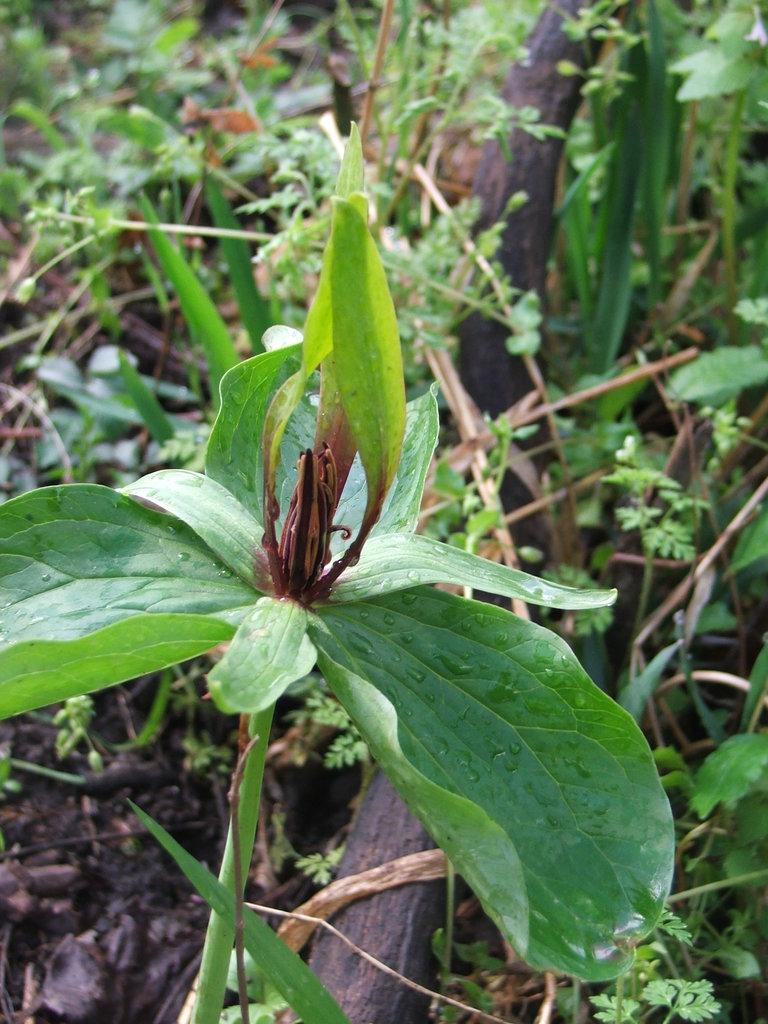What type of living organism can be seen in the image? There is a plant in the image. What is the condition of the plant in the image? Dew is visible on the plant. What object is made of wood in the image? There is a wooden stick in the image. Can you describe a part of the image that is not clear? There is a blurred part of the image. What type of scarecrow is visible in the image? There is no scarecrow present in the image. How does the balloon affect the visibility of the plant in the image? There is no balloon present in the image, so it cannot affect the visibility of the plant. 